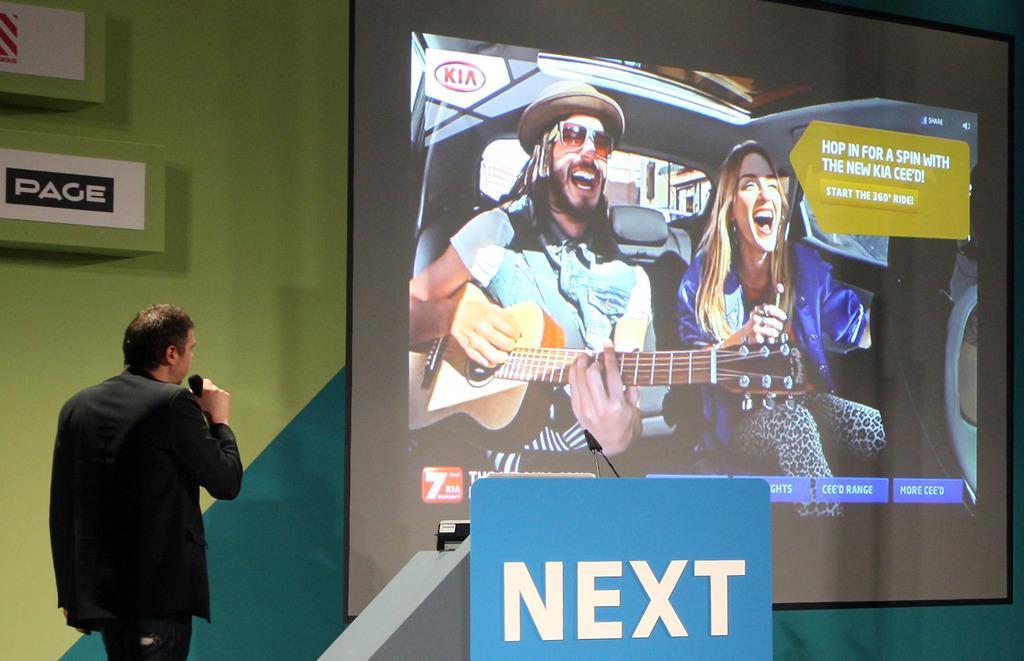How would you summarize this image in a sentence or two? In this image we can see a man is standing. He is wearing a black color suit and holding a mic in his hand. In the background, we can see a wall and a big screen. On the screen we can see one man and woman are sitting in a car. The man is playing guitar. At the bottom of the image, we can see a board. 